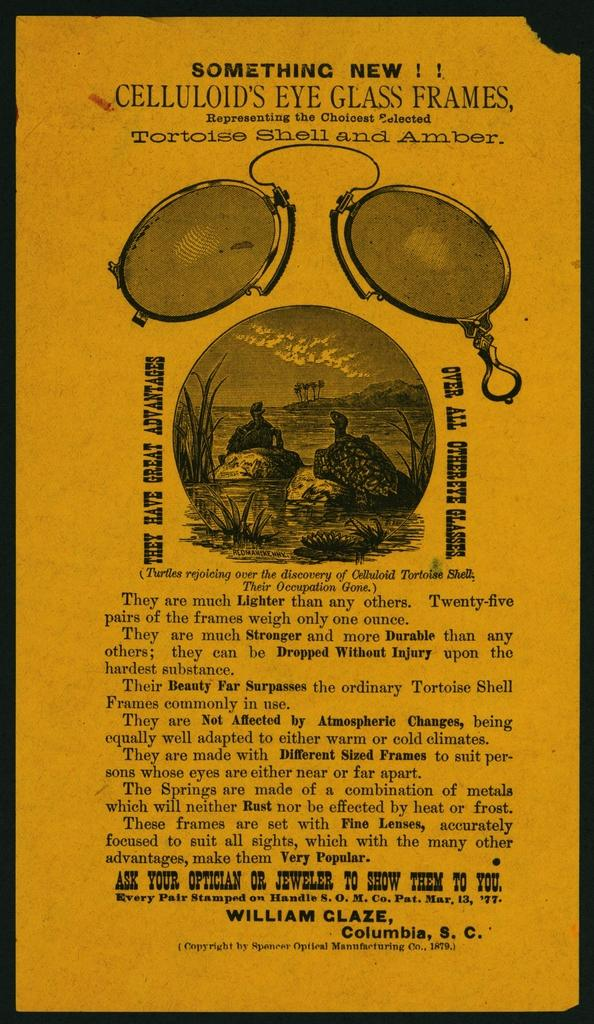<image>
Describe the image concisely. An eyeglass frame ad exclaims that it is, "Something New!" 